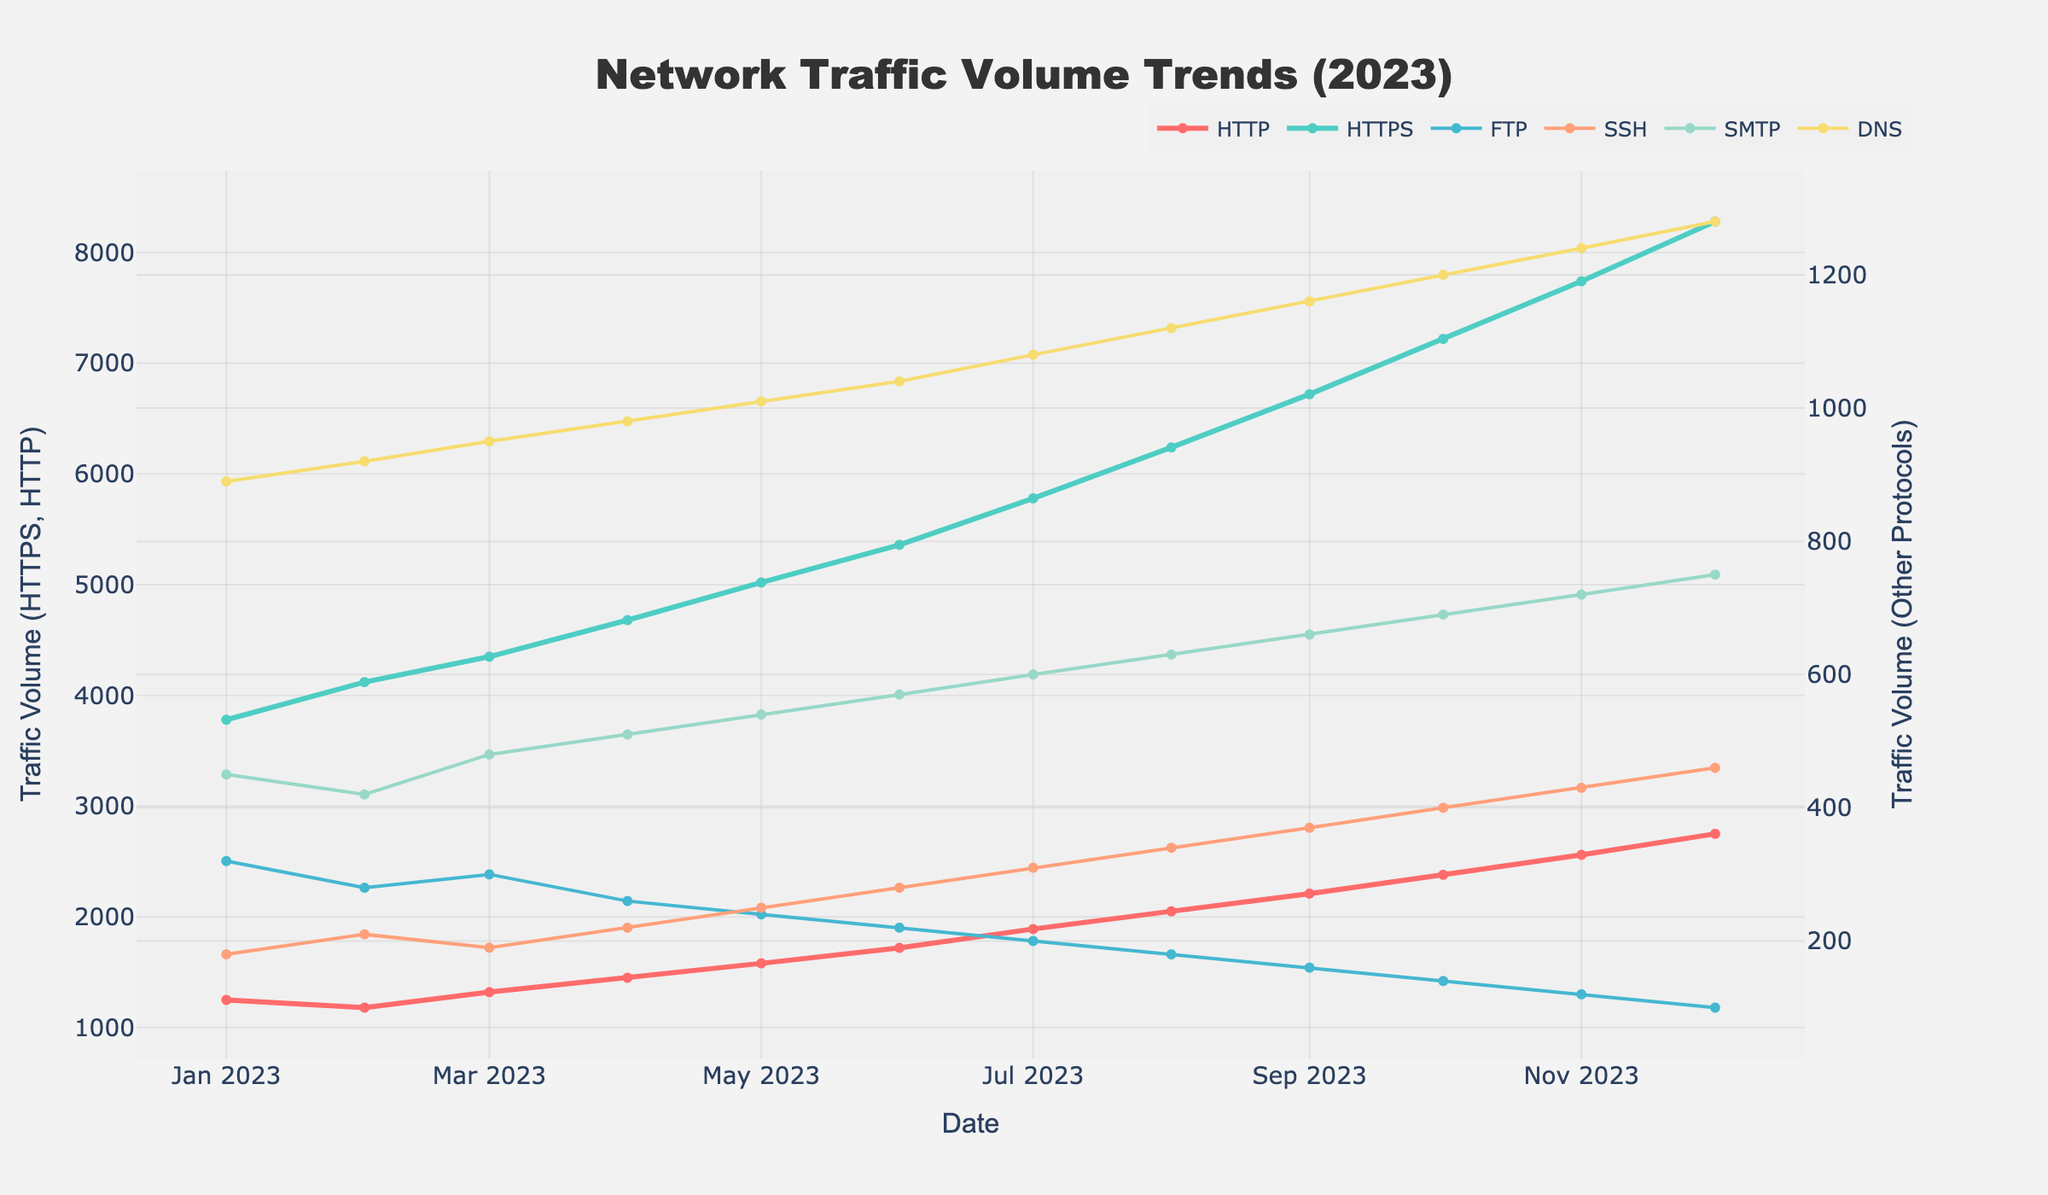Which protocol has the highest traffic volume in December 2023? Look for the line corresponding to December 2023 and compare the values of all protocols. HTTPS has the highest peak in December 2023.
Answer: HTTPS Which two months have the biggest increase in HTTP traffic volume? Identify the slope between every two consecutive points for the HTTP line. The largest increase occurs between November 2023 and December 2023. The second largest is between February 2023 and March 2023.
Answer: November-December, February-March What is the difference in traffic volume between SMTP and FTP in July 2023? Refer to the July 2023 point on the graph and subtract the FTP value from the SMTP value. SMTP = 600, FTP = 200, so 600 - 200 = 400.
Answer: 400 Which protocol showed consistent monthly growth throughout the year? Examine each protocol’s line from January 2023 to December 2023 to see if there are any downward trends or plateaus. HTTPS consistently increases every month.
Answer: HTTPS What was the average DNS traffic volume in the first quarter of 2023? Identify DNS values for January, February, and March 2023. Sum them up and divide by 3. DNS: (890 + 920 + 950) / 3 = 920.
Answer: 920 In which month did SSH reach its peak traffic volume and what was the value? Find the highest point in the SSH line and identify the corresponding month and value. The peak is in December 2023 with a value of 460.
Answer: December, 460 How much did HTTPS traffic increase from January to December 2023? Subtract the HTTPS value in January from its value in December. HTTPS: 8280 - 3780 = 4500.
Answer: 4500 Is the traffic volume for FTP higher in May 2023 or in October 2023? Compare the FTP values for May and October 2023. May FTP = 240, October FTP = 140. May is higher.
Answer: May Which protocol has the smallest variability (least fluctuation) over the year? Look at each protocol line and visually assess which one has the smallest changes. SSH shows the least fluctuation over the year with smaller changes month-to-month.
Answer: SSH During which month does DNS first cross 1000? Trace the DNS line until it first crosses the 1000 mark. It first crosses 1000 in May 2023.
Answer: May 